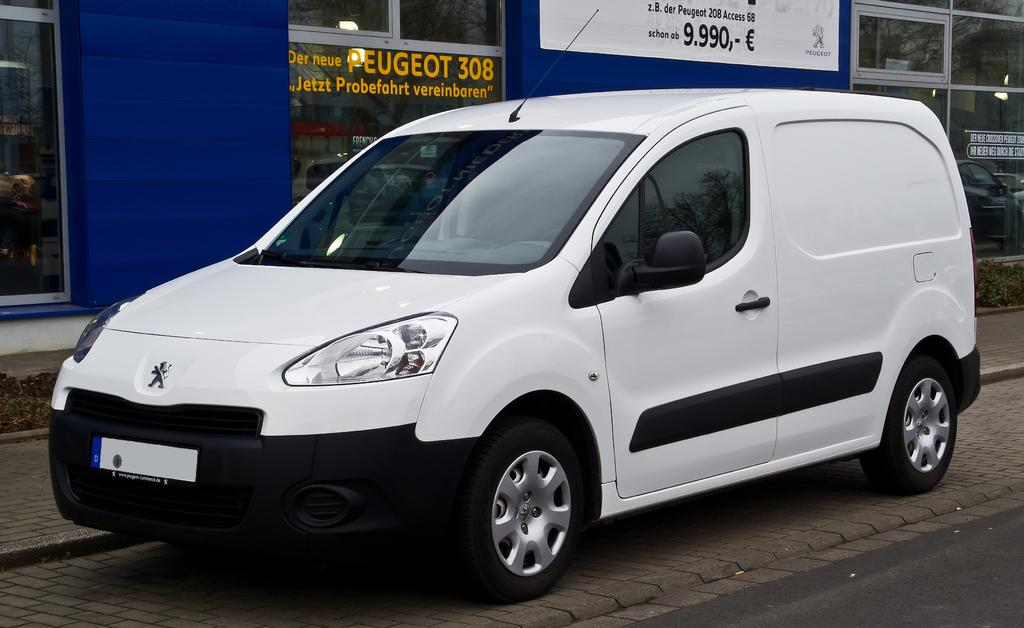What is the main feature in the middle of the image? There is a white color wall in the middle of the image. What can be seen in the background of the image? There is a window visible in the background of the image. What is written or displayed on the window? Text is visible on the window. How many dolls are sitting on the writer's nerve in the image? There are no dolls or writers present in the image, and therefore no such interaction can be observed. 